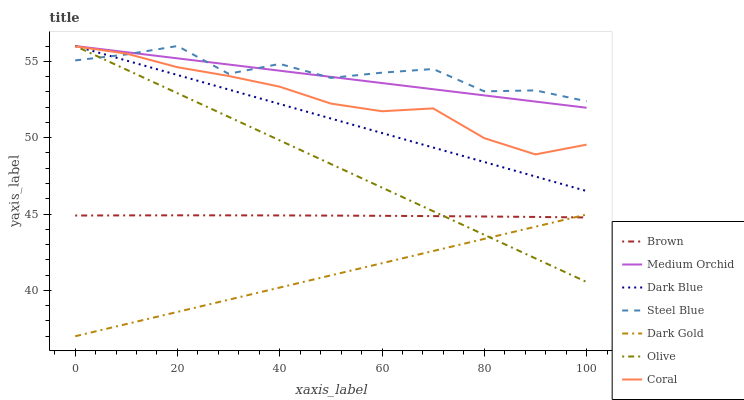Does Dark Gold have the minimum area under the curve?
Answer yes or no. Yes. Does Steel Blue have the maximum area under the curve?
Answer yes or no. Yes. Does Coral have the minimum area under the curve?
Answer yes or no. No. Does Coral have the maximum area under the curve?
Answer yes or no. No. Is Dark Blue the smoothest?
Answer yes or no. Yes. Is Steel Blue the roughest?
Answer yes or no. Yes. Is Dark Gold the smoothest?
Answer yes or no. No. Is Dark Gold the roughest?
Answer yes or no. No. Does Dark Gold have the lowest value?
Answer yes or no. Yes. Does Coral have the lowest value?
Answer yes or no. No. Does Olive have the highest value?
Answer yes or no. Yes. Does Dark Gold have the highest value?
Answer yes or no. No. Is Brown less than Medium Orchid?
Answer yes or no. Yes. Is Medium Orchid greater than Brown?
Answer yes or no. Yes. Does Medium Orchid intersect Olive?
Answer yes or no. Yes. Is Medium Orchid less than Olive?
Answer yes or no. No. Is Medium Orchid greater than Olive?
Answer yes or no. No. Does Brown intersect Medium Orchid?
Answer yes or no. No. 